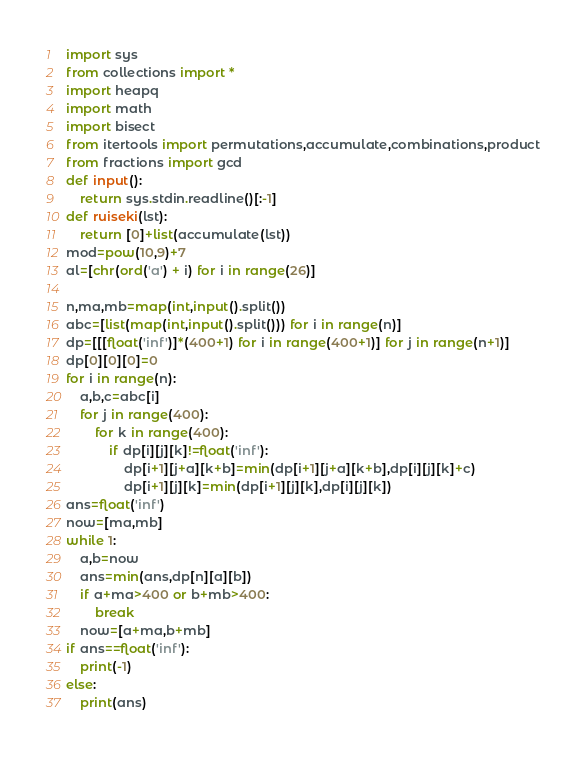<code> <loc_0><loc_0><loc_500><loc_500><_Python_>import sys
from collections import *
import heapq
import math
import bisect
from itertools import permutations,accumulate,combinations,product
from fractions import gcd
def input():
    return sys.stdin.readline()[:-1]
def ruiseki(lst):
    return [0]+list(accumulate(lst))
mod=pow(10,9)+7
al=[chr(ord('a') + i) for i in range(26)]

n,ma,mb=map(int,input().split())
abc=[list(map(int,input().split())) for i in range(n)]
dp=[[[float('inf')]*(400+1) for i in range(400+1)] for j in range(n+1)]
dp[0][0][0]=0
for i in range(n):
    a,b,c=abc[i]
    for j in range(400):
        for k in range(400):
            if dp[i][j][k]!=float('inf'):
                dp[i+1][j+a][k+b]=min(dp[i+1][j+a][k+b],dp[i][j][k]+c)
                dp[i+1][j][k]=min(dp[i+1][j][k],dp[i][j][k])
ans=float('inf')
now=[ma,mb]
while 1:
    a,b=now
    ans=min(ans,dp[n][a][b])
    if a+ma>400 or b+mb>400:
        break
    now=[a+ma,b+mb]
if ans==float('inf'):
    print(-1)
else:
    print(ans)</code> 